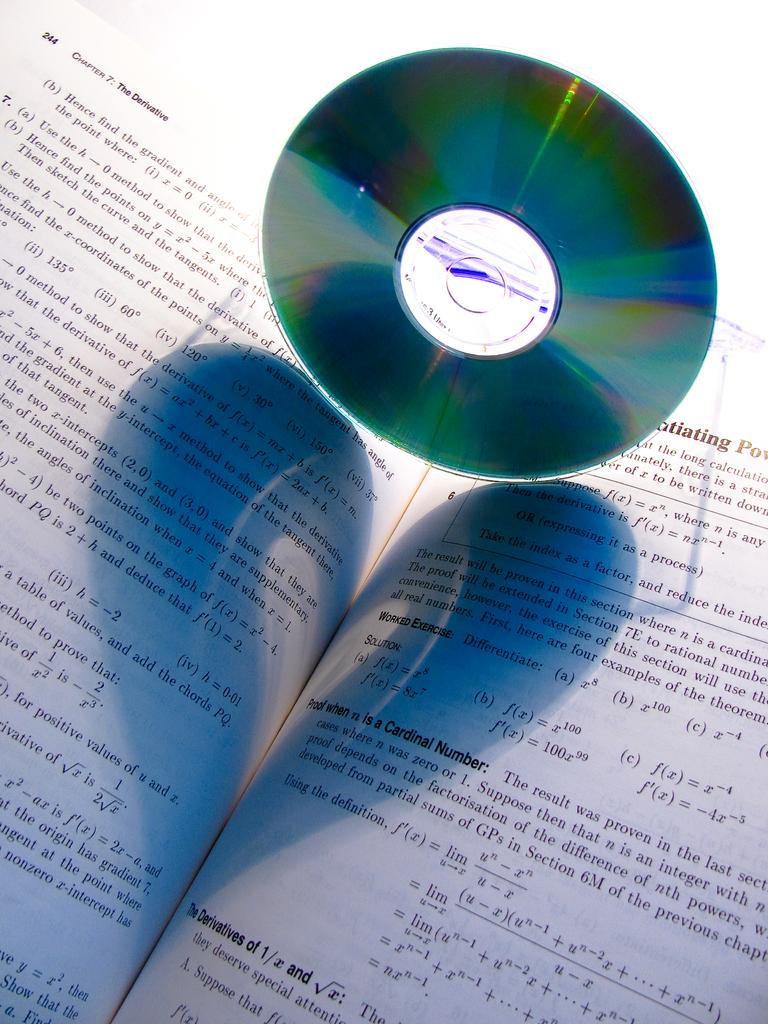<image>
Offer a succinct explanation of the picture presented. A CD holding a book open to Chapter 7, page 244. 